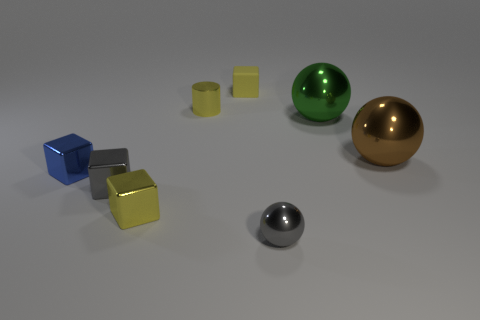Subtract 1 spheres. How many spheres are left? 2 Subtract all tiny rubber cubes. How many cubes are left? 3 Subtract all yellow spheres. How many blue cubes are left? 1 Add 2 purple things. How many objects exist? 10 Subtract all gray balls. How many balls are left? 2 Subtract 0 brown cylinders. How many objects are left? 8 Subtract all cylinders. How many objects are left? 7 Subtract all red blocks. Subtract all cyan spheres. How many blocks are left? 4 Subtract all yellow cubes. Subtract all gray blocks. How many objects are left? 5 Add 7 tiny gray metallic things. How many tiny gray metallic things are left? 9 